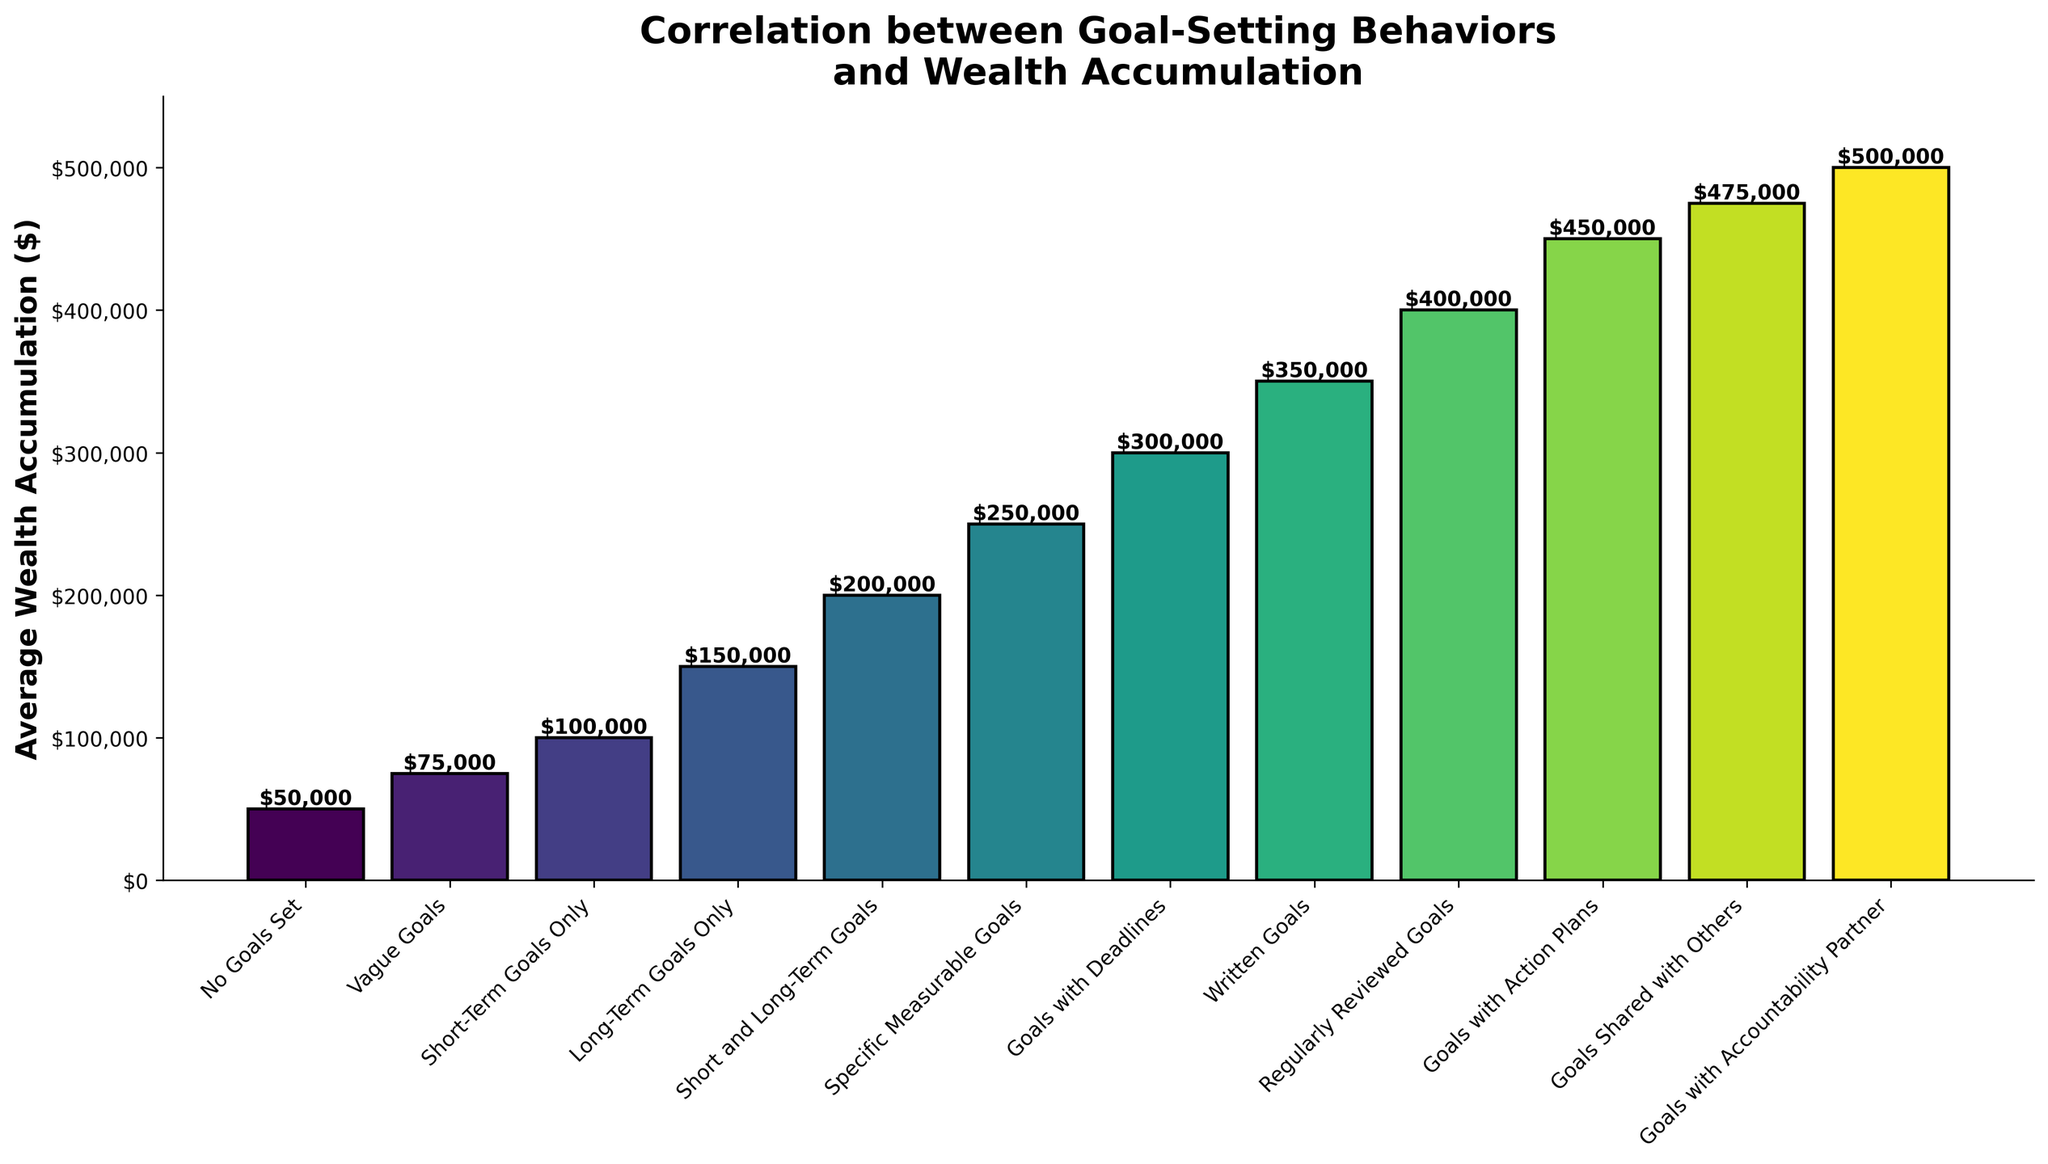What is the average wealth accumulation for "Goals Shared with Others"? Look at the bar marked "Goals Shared with Others" and read the height of the bar, which represents its value.
Answer: $475,000 Which goal-setting behavior corresponds to the highest average wealth accumulation? Compare the heights of all bars to find the tallest one. The behavior with the tallest bar corresponds to the highest average wealth accumulation.
Answer: Goals with Accountability Partner How much more average wealth is accumulated by those with "Goals with Action Plans" compared to those with "Vague Goals"? Subtract the average wealth accumulation for "Vague Goals" from the average wealth accumulation for "Goals with Action Plans" ($450,000 - $75,000).
Answer: $375,000 What is the difference in average wealth accumulation between those with "Written Goals" and those with "Short-Term Goals Only"? Subtract the average wealth accumulation for "Short-Term Goals Only" from the average wealth accumulation for "Written Goals" ($350,000 - $100,000).
Answer: $250,000 How does the average wealth accumulation for "Specific Measurable Goals" compare with "Short and Long-Term Goals"? Observe the heights of the bars for both "Specific Measurable Goals" and "Short and Long-Term Goals" to see which is higher.
Answer: Specific Measurable Goals is higher Which goal-setting behavior has the lowest average wealth accumulation? Identify the shortest bar among all the bars to determine which behavior corresponds to the lowest average wealth accumulation.
Answer: No Goals Set How much more wealth do individuals accumulate on average with "Regularly Reviewed Goals" compared to "No Goals Set"? Subtract the average wealth accumulation for "No Goals Set" from the average wealth accumulation for "Regularly Reviewed Goals" ($400,000 - $50,000).
Answer: $350,000 Are "Goals with Deadlines" more effective than "Long-Term Goals Only" in terms of average wealth accumulation? Compare the heights of the bars for "Goals with Deadlines" and "Long-Term Goals Only". "Goals with Deadlines" has a higher bar.
Answer: Yes What is the cumulative average wealth accumulation of all goal-setting behaviors that include the word "Goals"? Add the average wealth accumulations for all the behaviors: $50,000 + $75,000 + $100,000 + $150,000 + $200,000 + $250,000 + $300,000 + $350,000 + $400,000 + $450,000 + $475,000 + $500,000.
Answer: $3,300,000 On average, what is the difference in wealth accumulation between "Regularly Reviewed Goals" and "Vague Goals"? Subtract the average wealth accumulation for "Vague Goals" from the average wealth accumulation for "Regularly Reviewed Goals" ($400,000 - $75,000).
Answer: $325,000 